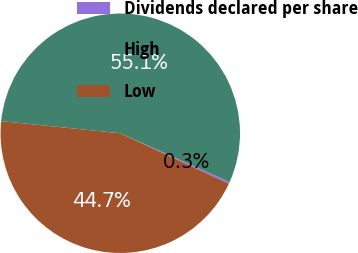Convert chart. <chart><loc_0><loc_0><loc_500><loc_500><pie_chart><fcel>Dividends declared per share<fcel>High<fcel>Low<nl><fcel>0.26%<fcel>55.05%<fcel>44.68%<nl></chart> 